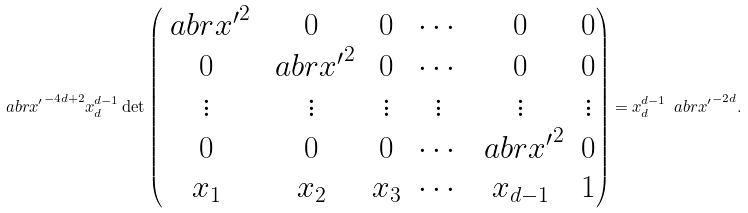Convert formula to latex. <formula><loc_0><loc_0><loc_500><loc_500>\ a b r { x ^ { \prime } } ^ { - 4 d + 2 } x _ { d } ^ { d - 1 } \det \begin{pmatrix} \ a b r { x ^ { \prime } } ^ { 2 } & 0 & 0 & \cdots & 0 & 0 \\ 0 & \ a b r { x ^ { \prime } } ^ { 2 } & 0 & \cdots & 0 & 0 \\ \vdots & \vdots & \vdots & \vdots & \vdots & \vdots \\ 0 & 0 & 0 & \cdots & \ a b r { x ^ { \prime } } ^ { 2 } & 0 \\ x _ { 1 } & x _ { 2 } & x _ { 3 } & \cdots & x _ { d - 1 } & 1 \end{pmatrix} = x _ { d } ^ { d - 1 } \ a b r { x ^ { \prime } } ^ { - 2 d } .</formula> 